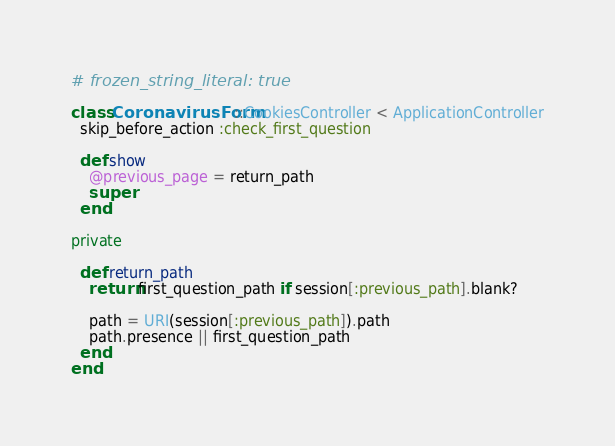Convert code to text. <code><loc_0><loc_0><loc_500><loc_500><_Ruby_># frozen_string_literal: true

class CoronavirusForm::CookiesController < ApplicationController
  skip_before_action :check_first_question

  def show
    @previous_page = return_path
    super
  end

private

  def return_path
    return first_question_path if session[:previous_path].blank?

    path = URI(session[:previous_path]).path
    path.presence || first_question_path
  end
end
</code> 